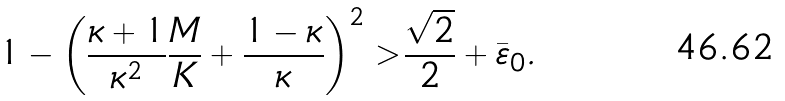Convert formula to latex. <formula><loc_0><loc_0><loc_500><loc_500>1 - \left ( \frac { \kappa + 1 } { \kappa ^ { 2 } } \frac { M } { K } + \frac { 1 - \kappa } { \kappa } \right ) ^ { 2 } > \frac { \sqrt { 2 } } { 2 } + \bar { \varepsilon } _ { 0 } .</formula> 